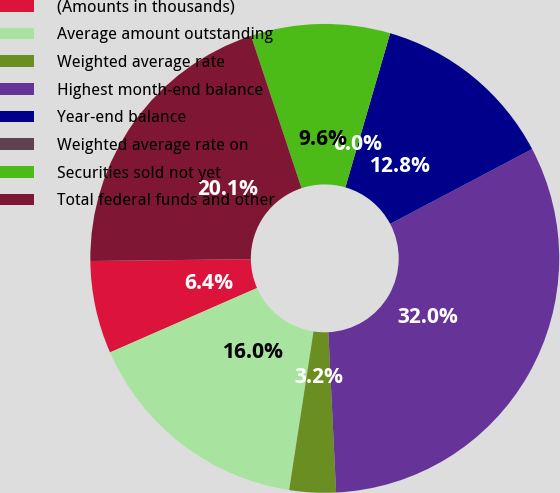<chart> <loc_0><loc_0><loc_500><loc_500><pie_chart><fcel>(Amounts in thousands)<fcel>Average amount outstanding<fcel>Weighted average rate<fcel>Highest month-end balance<fcel>Year-end balance<fcel>Weighted average rate on<fcel>Securities sold not yet<fcel>Total federal funds and other<nl><fcel>6.39%<fcel>16.0%<fcel>3.2%<fcel>31.95%<fcel>12.78%<fcel>0.0%<fcel>9.59%<fcel>20.09%<nl></chart> 